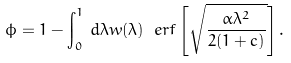Convert formula to latex. <formula><loc_0><loc_0><loc_500><loc_500>\phi = 1 - \int _ { 0 } ^ { 1 } \, d \lambda w ( \lambda ) \ e r f \left [ \sqrt { \frac { \alpha \lambda ^ { 2 } } { 2 ( 1 + c ) } } \right ] .</formula> 